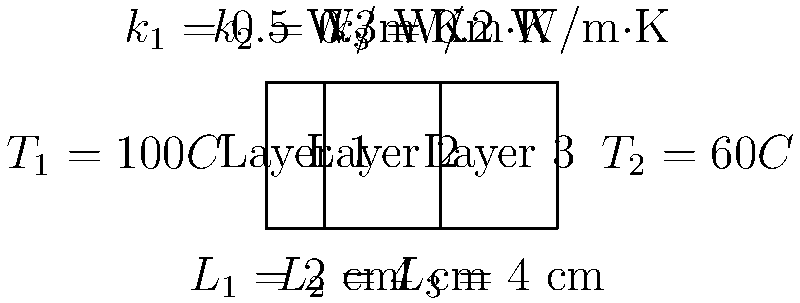As a former journalist with an understanding of complex systems, you're investigating the energy efficiency of a building. You come across a composite wall with three layers, as shown in the diagram. The wall has a surface area of 10 m². Calculate the heat transfer rate through this wall. To solve this problem, we'll use the concept of thermal resistance in series for a composite wall. Here's a step-by-step approach:

1) The heat transfer rate $q$ is given by:

   $$ q = \frac{\Delta T}{R_{total}} $$

   where $\Delta T$ is the temperature difference and $R_{total}$ is the total thermal resistance.

2) For a composite wall, the total thermal resistance is the sum of individual resistances:

   $$ R_{total} = R_1 + R_2 + R_3 $$

3) The thermal resistance for each layer is given by:

   $$ R = \frac{L}{kA} $$

   where $L$ is the thickness, $k$ is the thermal conductivity, and $A$ is the surface area.

4) Calculate the resistances:
   
   $R_1 = \frac{0.02}{0.5 \times 10} = 0.004$ K/W
   
   $R_2 = \frac{0.04}{0.3 \times 10} = 0.0133$ K/W
   
   $R_3 = \frac{0.04}{0.2 \times 10} = 0.02$ K/W

5) Sum up the resistances:

   $R_{total} = 0.004 + 0.0133 + 0.02 = 0.0373$ K/W

6) Calculate the heat transfer rate:

   $$ q = \frac{100 - 60}{0.0373} = 1072.39 \text{ W} $$

Therefore, the heat transfer rate through the wall is approximately 1072 W.
Answer: 1072 W 